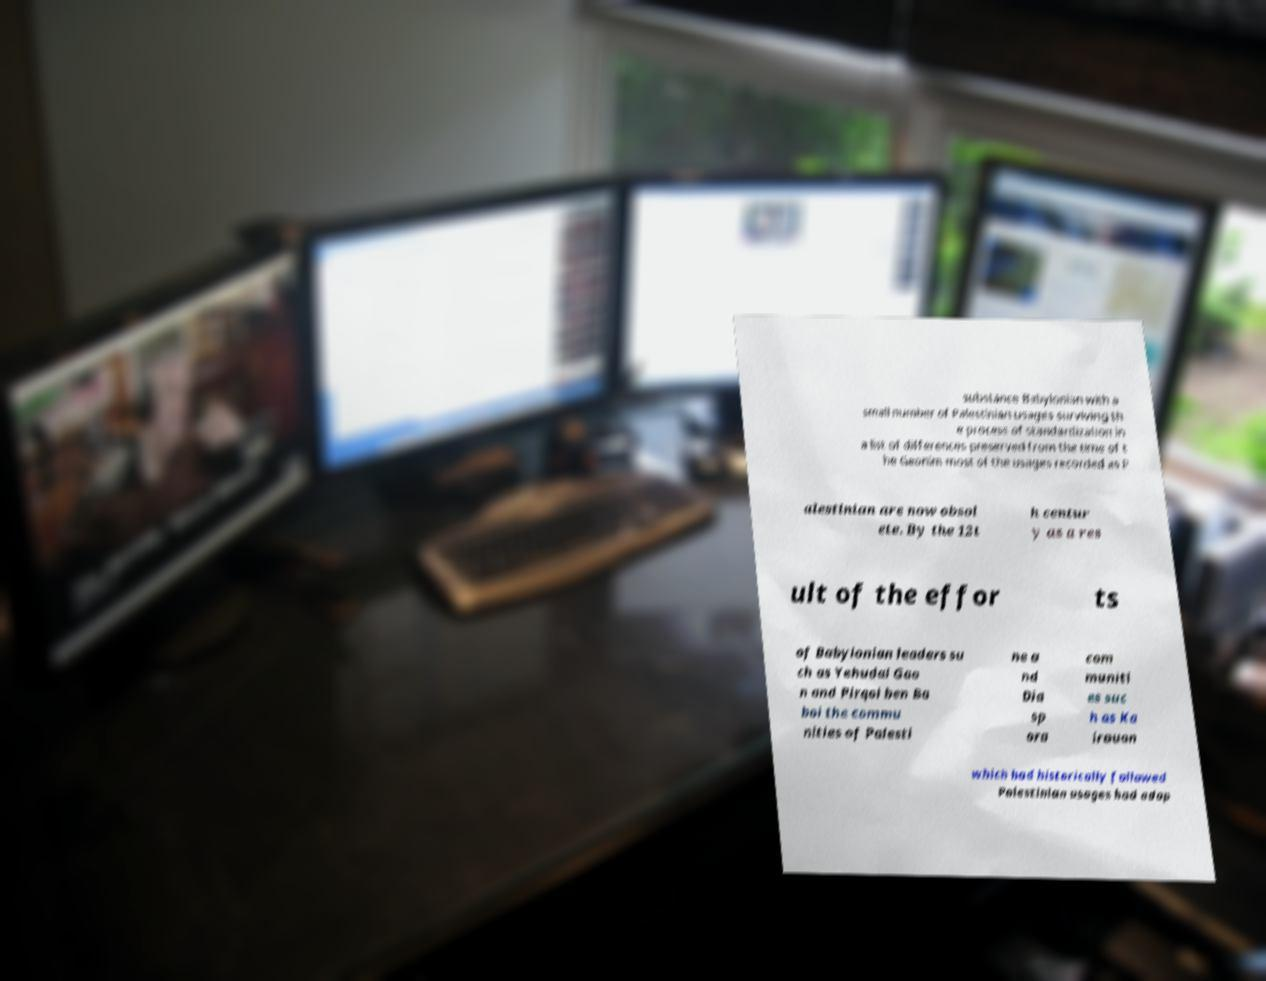For documentation purposes, I need the text within this image transcribed. Could you provide that? substance Babylonian with a small number of Palestinian usages surviving th e process of standardization in a list of differences preserved from the time of t he Geonim most of the usages recorded as P alestinian are now obsol ete. By the 12t h centur y as a res ult of the effor ts of Babylonian leaders su ch as Yehudai Gao n and Pirqoi ben Ba boi the commu nities of Palesti ne a nd Dia sp ora com muniti es suc h as Ka irouan which had historically followed Palestinian usages had adop 